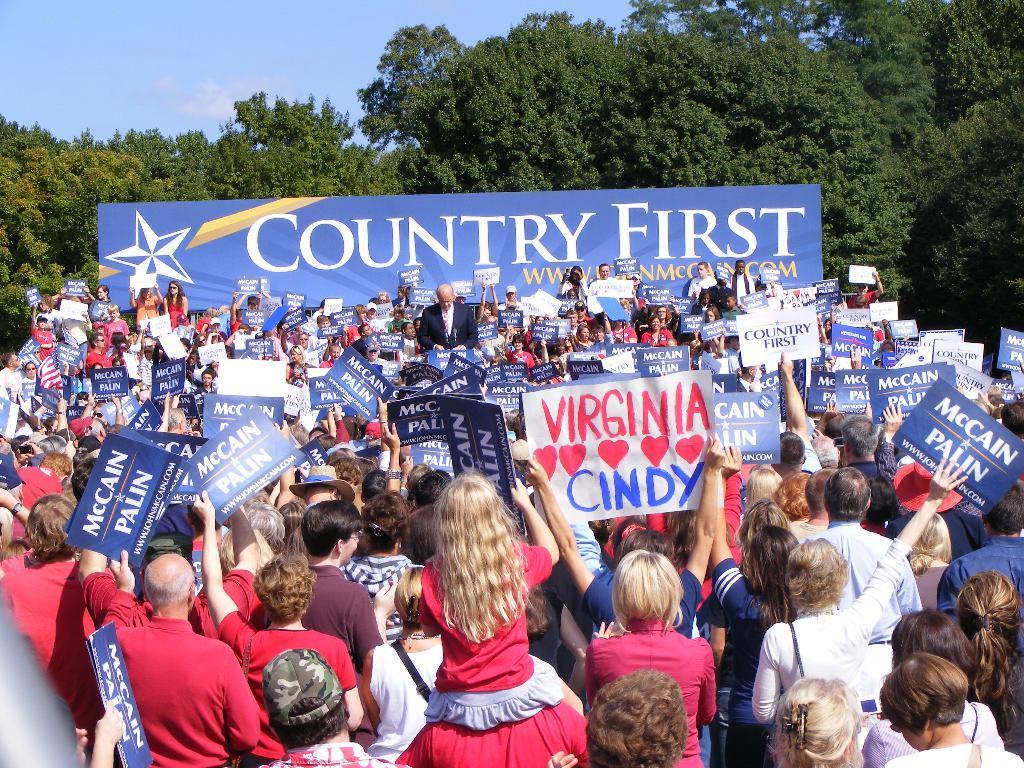In one or two sentences, can you explain what this image depicts? In this picture I can see many people were holding the posters and banners. In the back there is a man who is wearing suit. He is standing in the center of this group. In the background I can see the banner and many trees. At the top I can see the sky and clouds. 